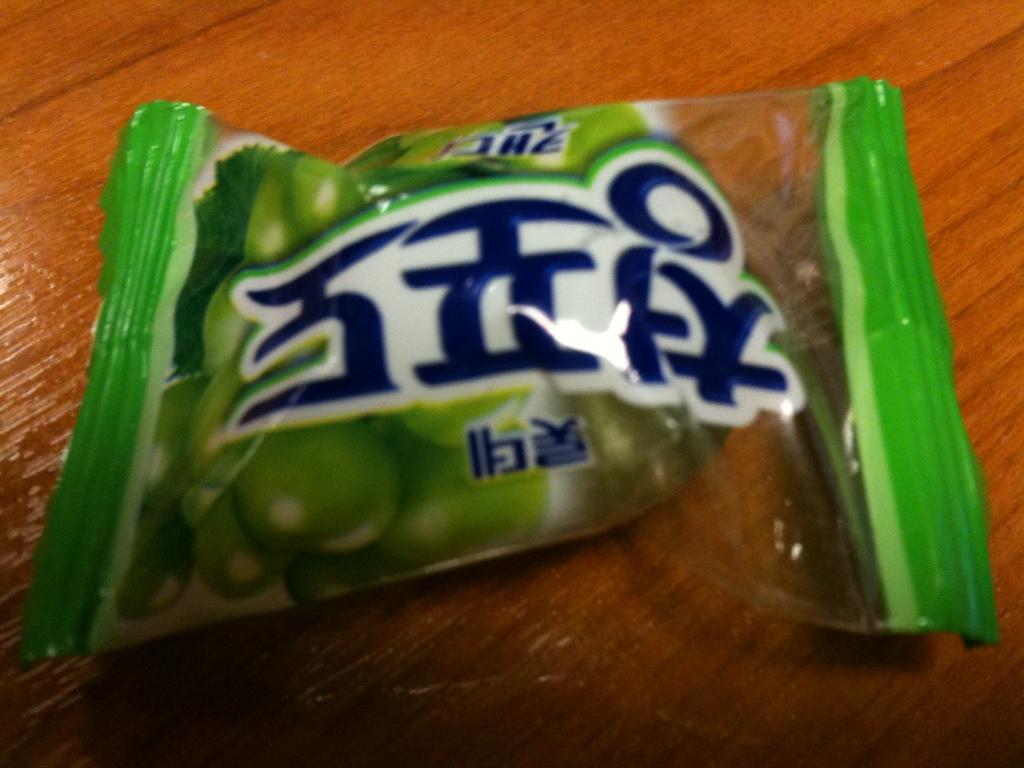Is that healthy or unhealthy?
Your answer should be compact. Answering does not require reading text in the image. 